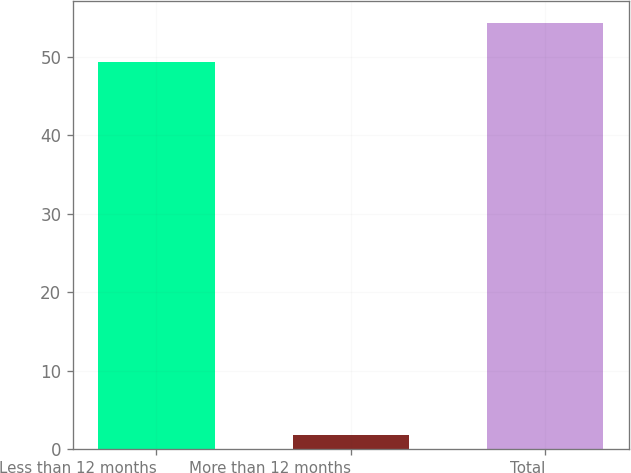<chart> <loc_0><loc_0><loc_500><loc_500><bar_chart><fcel>Less than 12 months<fcel>More than 12 months<fcel>Total<nl><fcel>49.4<fcel>1.8<fcel>54.34<nl></chart> 